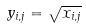<formula> <loc_0><loc_0><loc_500><loc_500>y _ { i , j } = \sqrt { x _ { i , j } }</formula> 